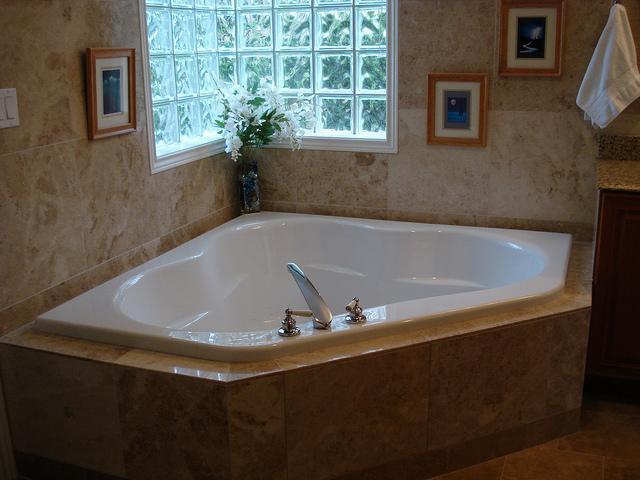How many pictures are on the wall?
Give a very brief answer. 3. 